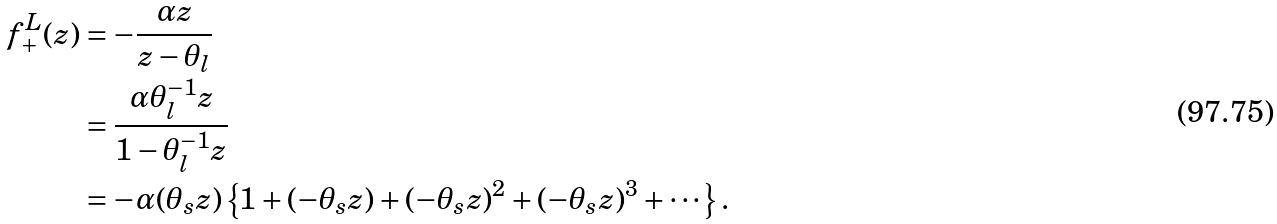Convert formula to latex. <formula><loc_0><loc_0><loc_500><loc_500>f ^ { L } _ { + } ( z ) & = - \frac { \alpha z } { z - \theta _ { l } } \\ & = \frac { \alpha \theta _ { l } ^ { - 1 } z } { 1 - \theta _ { l } ^ { - 1 } z } \\ & = - \alpha ( \theta _ { s } z ) \left \{ 1 + ( - \theta _ { s } z ) + ( - \theta _ { s } z ) ^ { 2 } + ( - \theta _ { s } z ) ^ { 3 } + \cdots \right \} .</formula> 